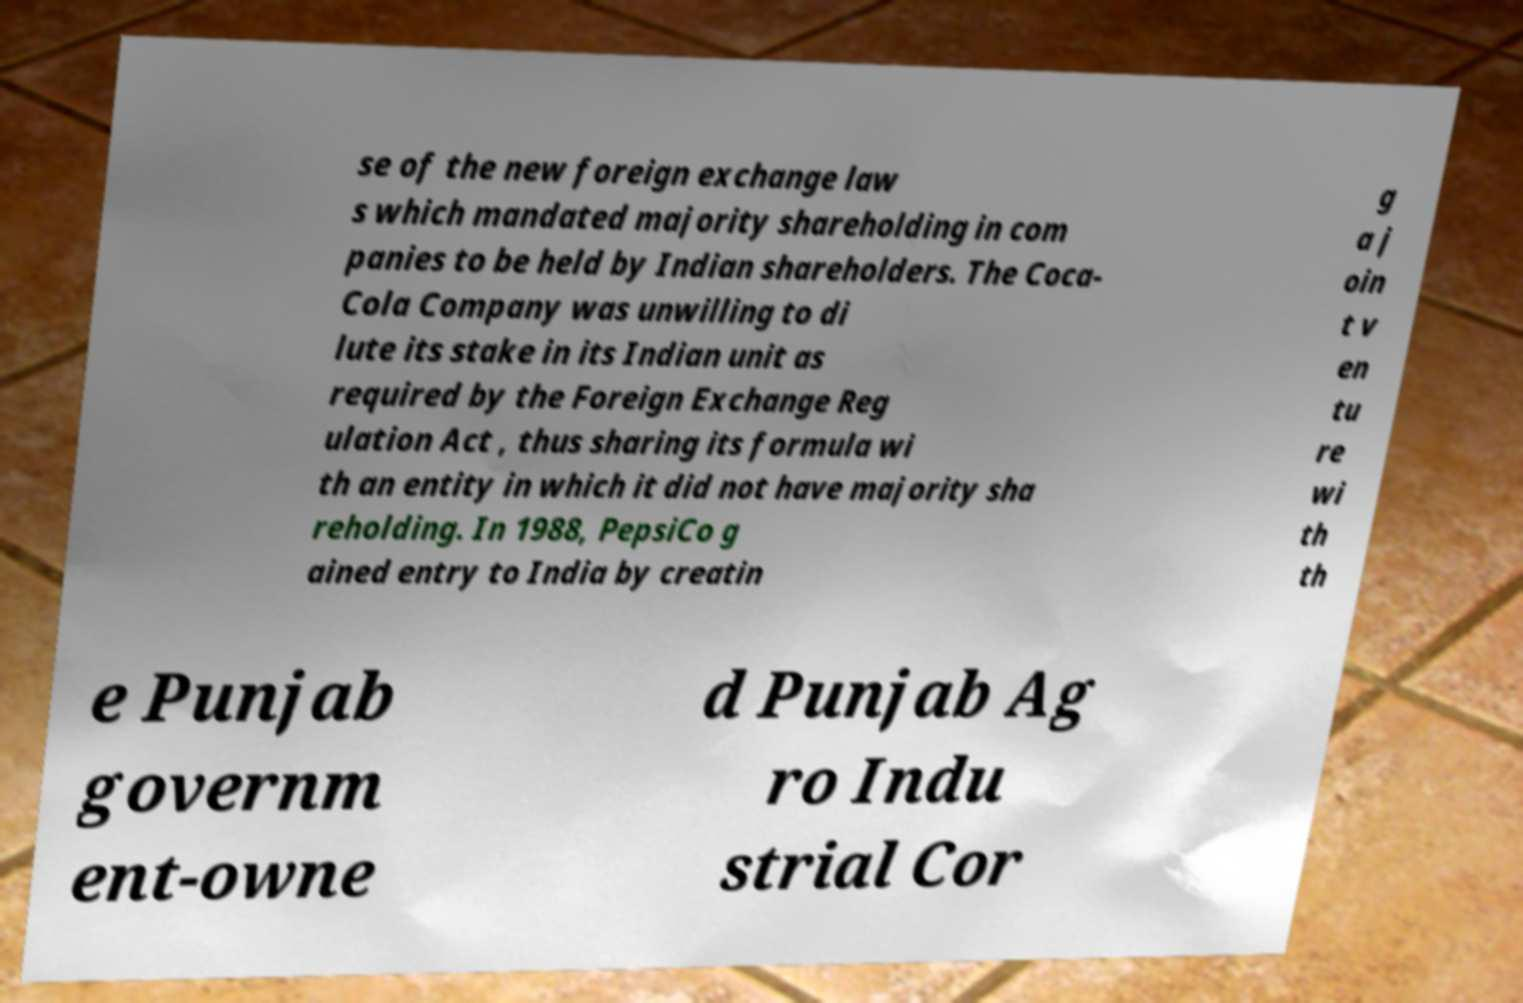Can you accurately transcribe the text from the provided image for me? se of the new foreign exchange law s which mandated majority shareholding in com panies to be held by Indian shareholders. The Coca- Cola Company was unwilling to di lute its stake in its Indian unit as required by the Foreign Exchange Reg ulation Act , thus sharing its formula wi th an entity in which it did not have majority sha reholding. In 1988, PepsiCo g ained entry to India by creatin g a j oin t v en tu re wi th th e Punjab governm ent-owne d Punjab Ag ro Indu strial Cor 